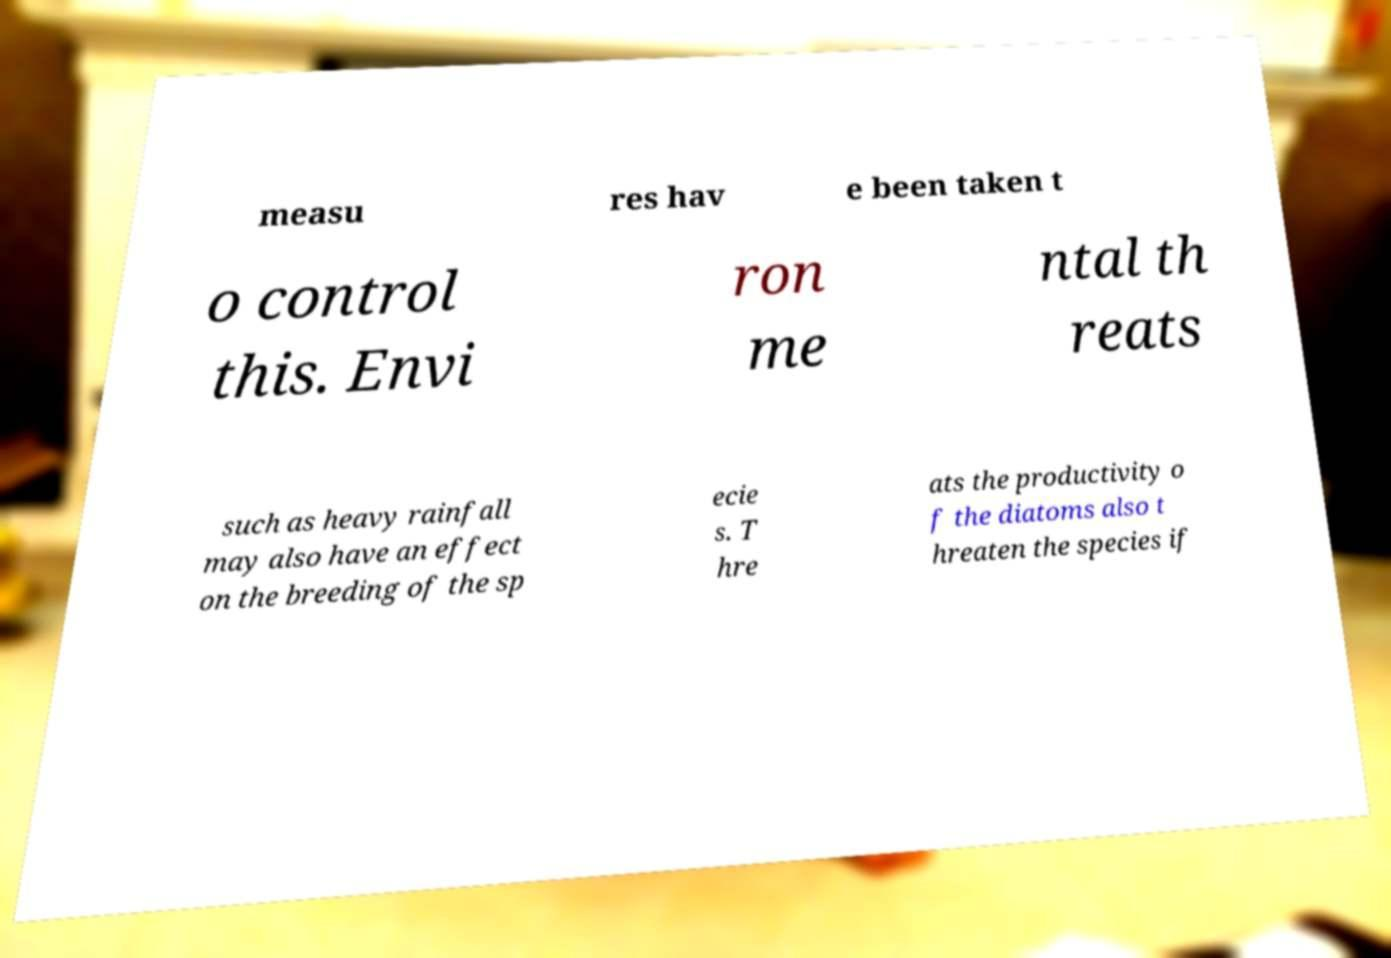I need the written content from this picture converted into text. Can you do that? measu res hav e been taken t o control this. Envi ron me ntal th reats such as heavy rainfall may also have an effect on the breeding of the sp ecie s. T hre ats the productivity o f the diatoms also t hreaten the species if 